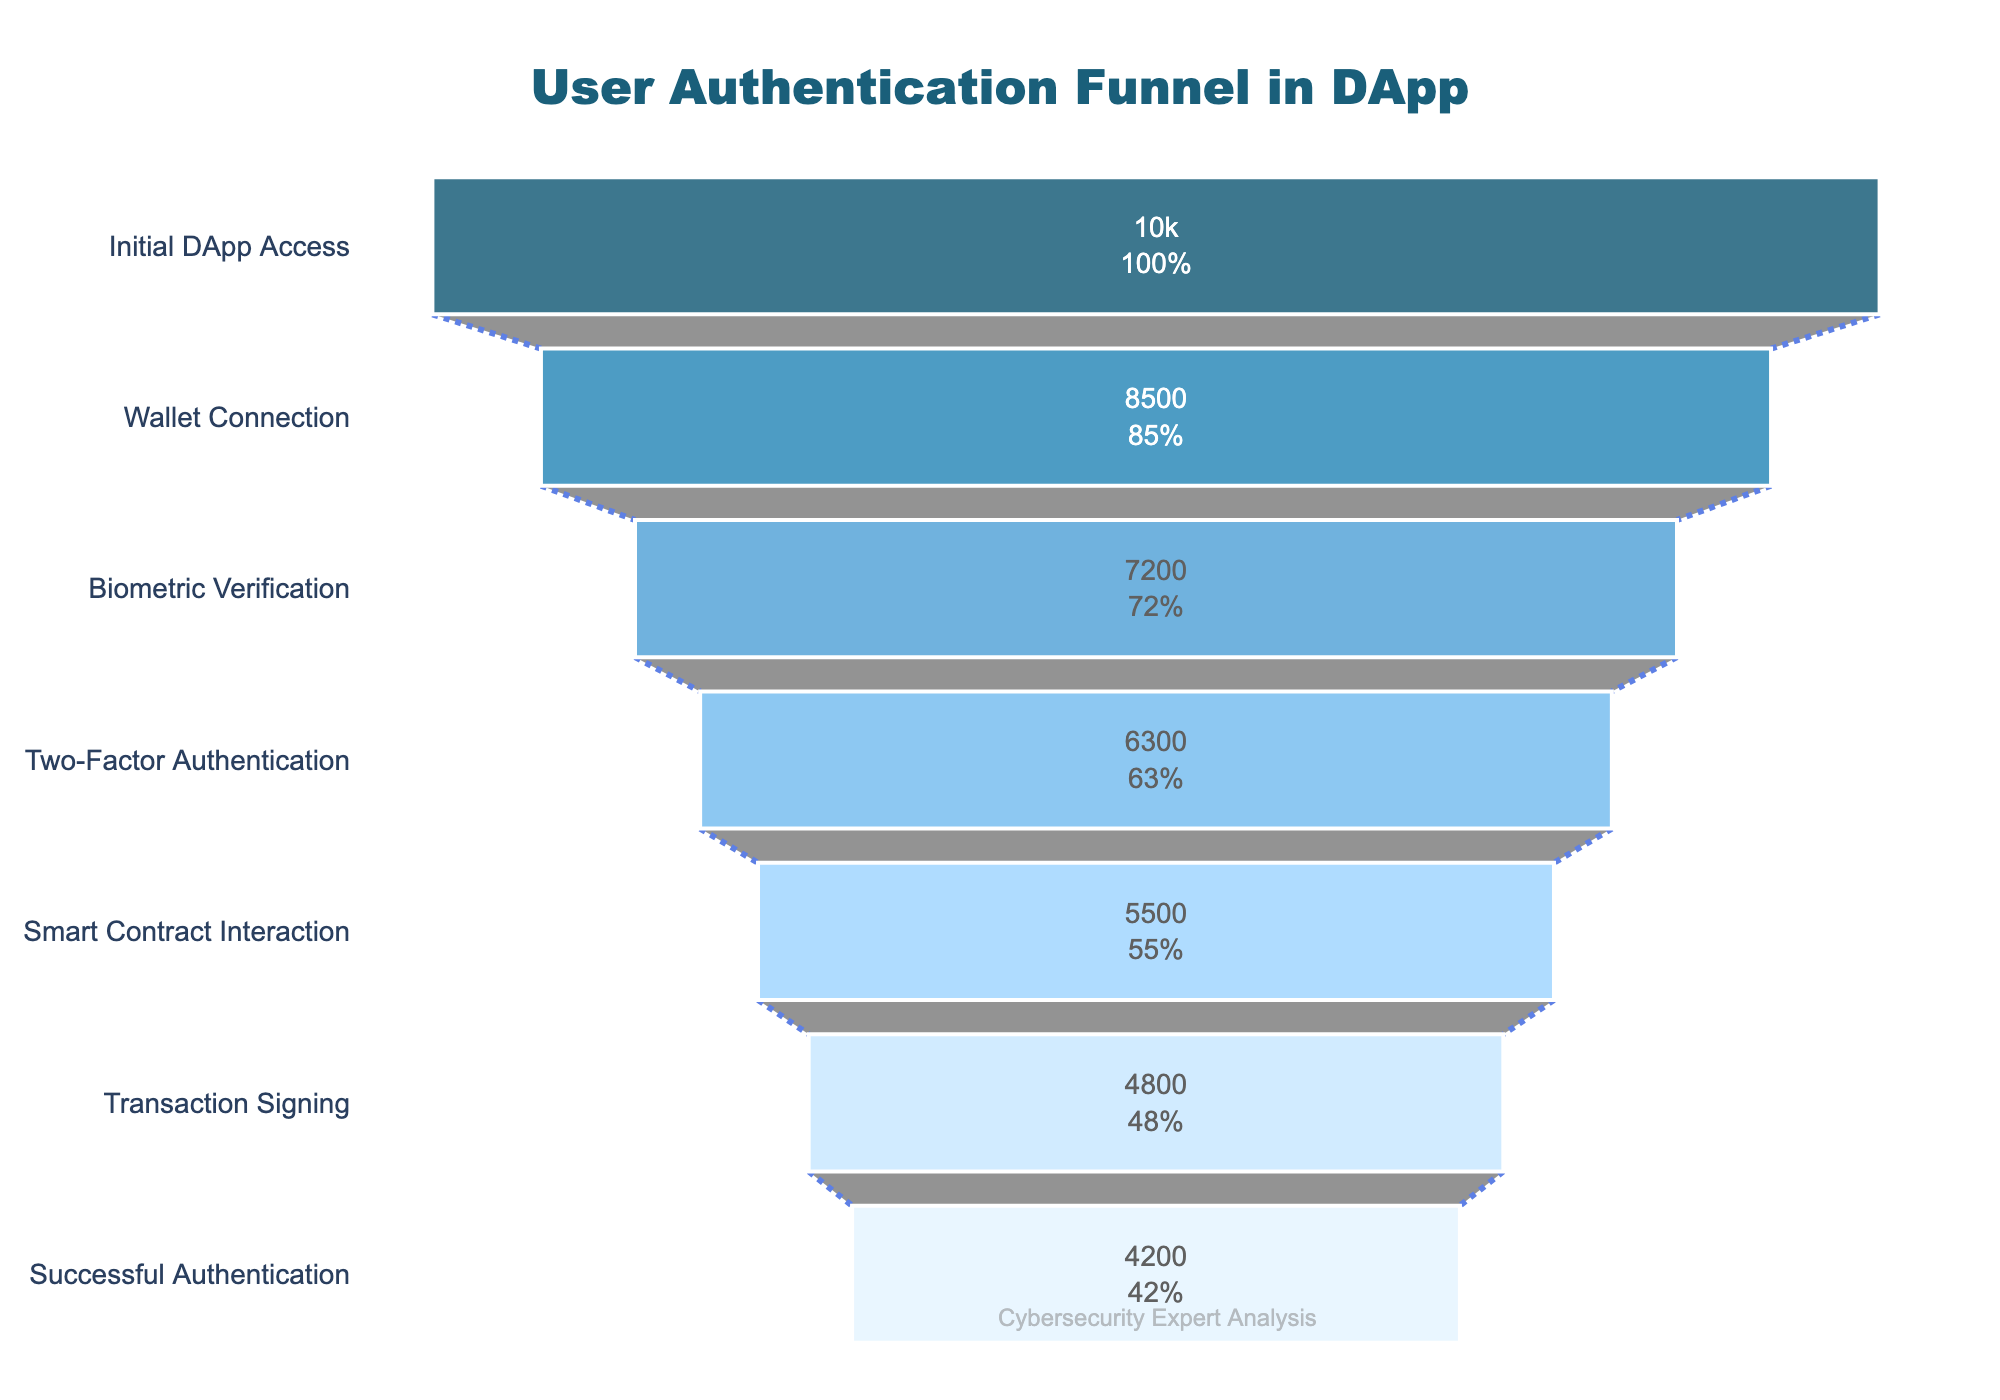How many users successfully authenticated? To find the number of users who successfully authenticated, look at the last step in the funnel chart labeled "Successful Authentication" and read the associated user count.
Answer: 4200 What percentage of users who accessed the DApp initially completed biometric verification? Locate the "Biometric Verification" step in the funnel chart and note its user count (7200). Compare this to the initial DApp access count (10000). Calculate the percentage as (7200 / 10000) * 100.
Answer: 72% Which step saw the highest drop in user count, and what is the number of users lost? To identify the step with the highest drop, compare the differences in user counts between consecutive steps. The highest difference is between "Wallet Connection" (8500) and "Initial DApp Access" (10000), resulting in a loss of 1500 users.
Answer: Wallet Connection, 1500 users lost What is the overall retention rate from initial access to successful authentication? Start with the initial access count (10000) and the final count of users who successfully authenticated (4200). Calculate the retention rate as (4200 / 10000) * 100.
Answer: 42% How does the user count at the Smart Contract Interaction step compare to that at the Transaction Signing step? Identify the user counts at the "Smart Contract Interaction" step (5500) and the "Transaction Signing" step (4800). Calculate the difference as 5500 - 4800 to find how many more users were at the Smart Contract Interaction step.
Answer: 700 more users What is the cumulative percentage loss from Initial DApp Access to Biometric Verification? To calculate cumulative percentage loss, analyze each step up to Biometric Verification. From initial access (10000) to wallet connection (8500), the loss is 15%, then to biometric verification (7200), the loss is (1150/10000)*100%. Combine both losses: 15% + 13%.
Answer: 28% How many users dropped out after the Two-Factor Authentication step? Look at the user counts at "Two-Factor Authentication" (6300) and the next step, "Smart Contract Interaction" (5500). The drop is calculated as 6300 - 5500.
Answer: 800 users Was the percentage loss greater from Wallet Connection to Biometric Verification or Biometric Verification to Two-Factor Authentication? Calculate the percentage losses for both transitions: From Wallet Connection (8500) to Biometric Verification (7200) is (8500-7200)/8500*100 = 15.3%. From Biometric Verification to Two-Factor Authentication is (7200-6300)/7200*100 = 12.5%. Compare both percentages.
Answer: Wallet Connection to Biometric Verification Which step experienced the smallest user drop-off and what was that drop-off? Analyze the differences between each step to find the smallest value. The difference between "Transaction Signing" (4800) and "Successful Authentication" (4200) is 600, which is the smallest drop-off in the steps listed.
Answer: Transaction Signing to Successful Authentication, 600 users 